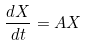Convert formula to latex. <formula><loc_0><loc_0><loc_500><loc_500>\frac { d X } { d t } = A X</formula> 